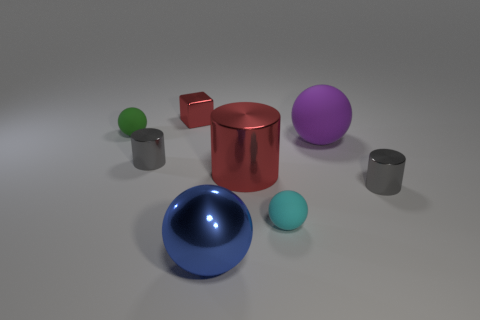Subtract all brown spheres. Subtract all red blocks. How many spheres are left? 4 Add 2 red things. How many objects exist? 10 Subtract all cylinders. How many objects are left? 5 Subtract all cyan matte spheres. Subtract all large red objects. How many objects are left? 6 Add 5 large red metallic objects. How many large red metallic objects are left? 6 Add 7 yellow matte spheres. How many yellow matte spheres exist? 7 Subtract 0 yellow spheres. How many objects are left? 8 